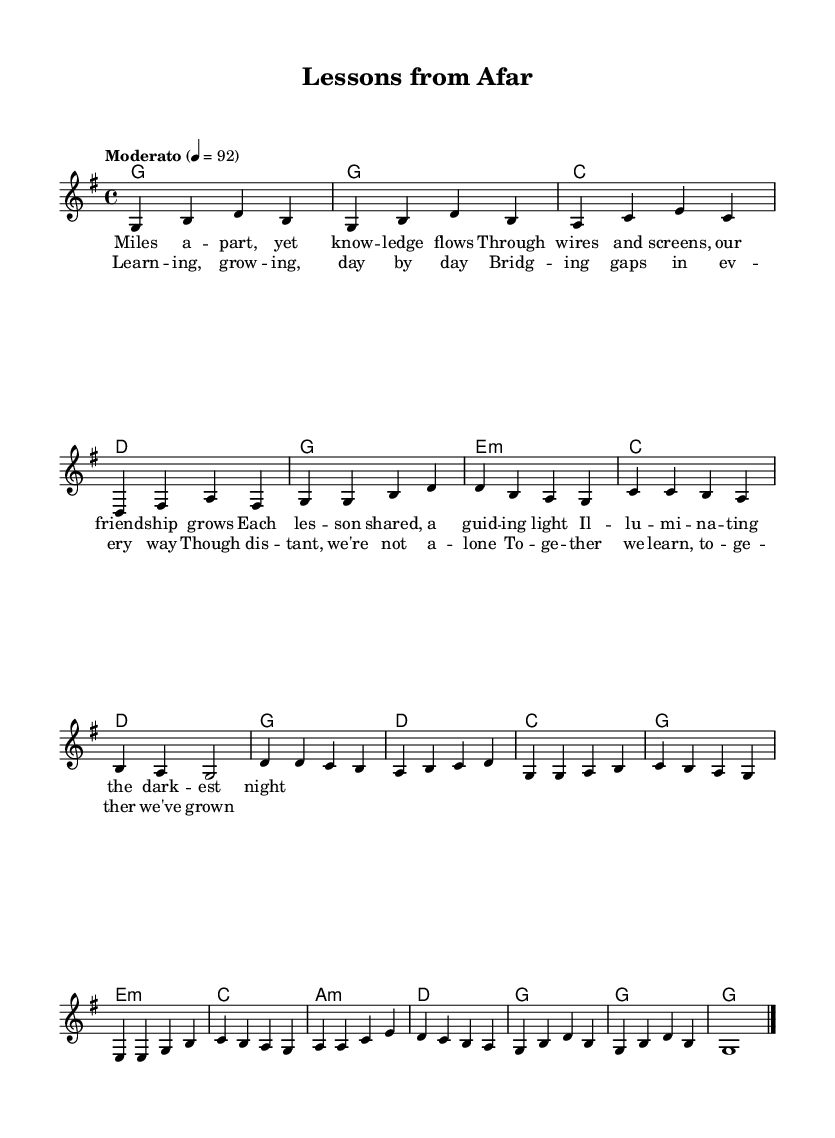What is the key signature of this music? The key signature is G major, which has one sharp (F#). It can be identified at the beginning of the staff.
Answer: G major What is the time signature of this music? The time signature is 4/4, indicated at the beginning of the sheet music. This means there are four beats in a measure.
Answer: 4/4 What is the tempo marking of this piece? The tempo marking indicates "Moderato," which refers to a moderate speed. This is specified in Italian and located above the staff.
Answer: Moderato How many measures are there in the verse section? By examining the verse section, we find it contains four measures. Each measure is separated by a vertical line.
Answer: Four What is the main theme of the lyrics? The main theme of the lyrics explores education and personal growth through the connection of technology and friendship. This can be derived from the content of both the verse and chorus.
Answer: Education and personal growth In what section does the lyric "Together we learn, together we've grown" appear? This lyric appears in the chorus section of the song, which is distinguished from the verse by its lyrical and melodic patterns.
Answer: Chorus What type of chords are primarily used throughout the song? The chords primarily consist of major and minor chords, typical in folk music, creating a sense of warmth and familiarity. This can be deduced from the chord names provided in the harmonies section.
Answer: Major and minor chords 